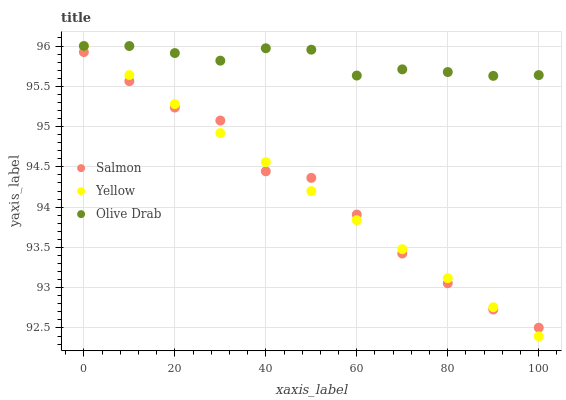Does Yellow have the minimum area under the curve?
Answer yes or no. Yes. Does Olive Drab have the maximum area under the curve?
Answer yes or no. Yes. Does Olive Drab have the minimum area under the curve?
Answer yes or no. No. Does Yellow have the maximum area under the curve?
Answer yes or no. No. Is Yellow the smoothest?
Answer yes or no. Yes. Is Salmon the roughest?
Answer yes or no. Yes. Is Olive Drab the smoothest?
Answer yes or no. No. Is Olive Drab the roughest?
Answer yes or no. No. Does Yellow have the lowest value?
Answer yes or no. Yes. Does Olive Drab have the lowest value?
Answer yes or no. No. Does Yellow have the highest value?
Answer yes or no. Yes. Is Salmon less than Olive Drab?
Answer yes or no. Yes. Is Olive Drab greater than Salmon?
Answer yes or no. Yes. Does Olive Drab intersect Yellow?
Answer yes or no. Yes. Is Olive Drab less than Yellow?
Answer yes or no. No. Is Olive Drab greater than Yellow?
Answer yes or no. No. Does Salmon intersect Olive Drab?
Answer yes or no. No. 